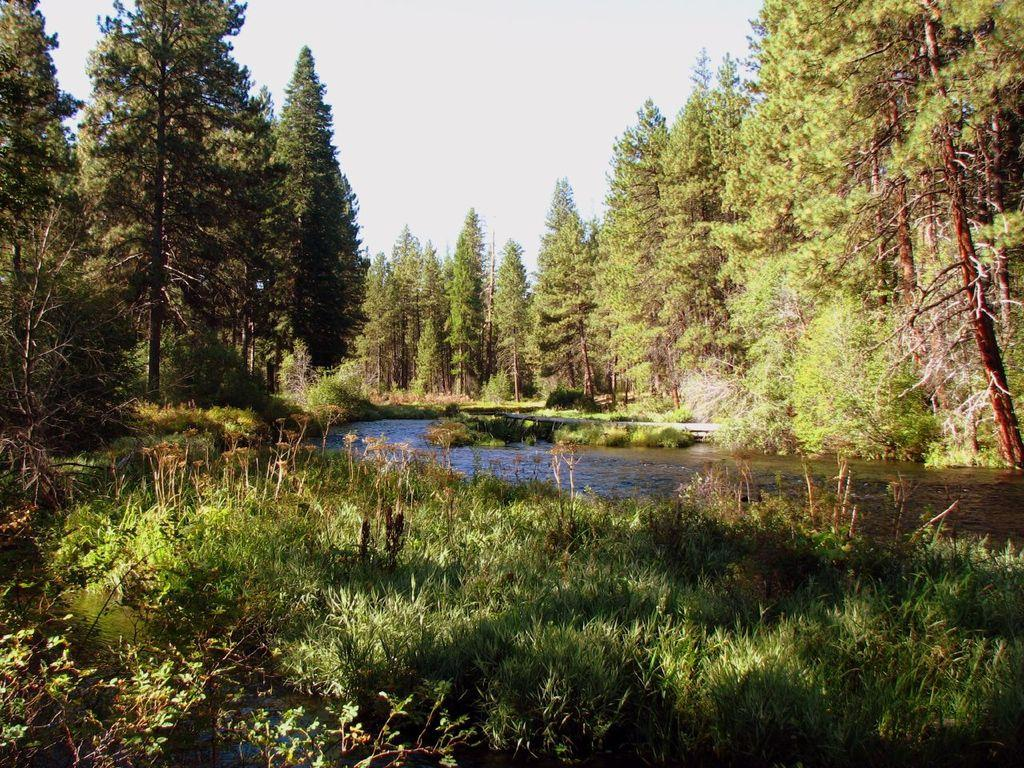What type of vegetation can be seen in the image? There are trees in the image. What else can be seen on the ground in the image? There is grass in the image. What is the third element visible in the image? There is water in the image. What is visible at the top of the image? The sky is visible at the top of the image. Can you tell me how many swings are present in the image? There are no swings present in the image; it features trees, grass, water, and the sky. What might be causing a sore throat in the image? There is no indication of a sore throat or any related cause in the image. 